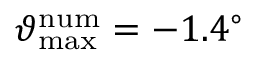<formula> <loc_0><loc_0><loc_500><loc_500>\vartheta _ { \max } ^ { n u m } = - 1 . 4 ^ { \circ }</formula> 